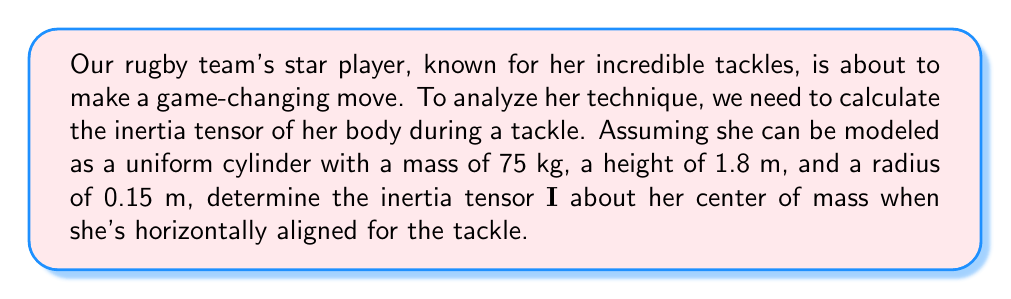Solve this math problem. Let's approach this step-by-step:

1) The inertia tensor for a uniform cylinder about its center of mass is given by:

   $$\mathbf{I} = \begin{pmatrix}
   I_{xx} & 0 & 0 \\
   0 & I_{yy} & 0 \\
   0 & 0 & I_{zz}
   \end{pmatrix}$$

2) For a cylinder with mass $m$, radius $r$, and height $h$:
   
   $I_{xx} = I_{yy} = \frac{1}{12}m(3r^2 + h^2)$
   $I_{zz} = \frac{1}{2}mr^2$

3) Given:
   $m = 75$ kg
   $h = 1.8$ m
   $r = 0.15$ m

4) Calculate $I_{xx}$ and $I_{yy}$:
   
   $I_{xx} = I_{yy} = \frac{1}{12} \cdot 75 \cdot (3 \cdot 0.15^2 + 1.8^2)$
   $= 6.25 \cdot (0.0675 + 3.24) = 6.25 \cdot 3.3075 = 20.671875$ kg·m²

5) Calculate $I_{zz}$:
   
   $I_{zz} = \frac{1}{2} \cdot 75 \cdot 0.15^2 = 0.84375$ kg·m²

6) The inertia tensor is therefore:

   $$\mathbf{I} = \begin{pmatrix}
   20.671875 & 0 & 0 \\
   0 & 20.671875 & 0 \\
   0 & 0 & 0.84375
   \end{pmatrix}$$ kg·m²
Answer: $$\mathbf{I} = \begin{pmatrix}
20.671875 & 0 & 0 \\
0 & 20.671875 & 0 \\
0 & 0 & 0.84375
\end{pmatrix}$$ kg·m² 